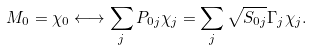<formula> <loc_0><loc_0><loc_500><loc_500>M _ { 0 } = \chi _ { 0 } \longleftrightarrow \sum _ { j } P _ { 0 j } \chi _ { j } = \sum _ { j } \sqrt { S _ { 0 j } } \Gamma _ { j } \chi _ { j } .</formula> 